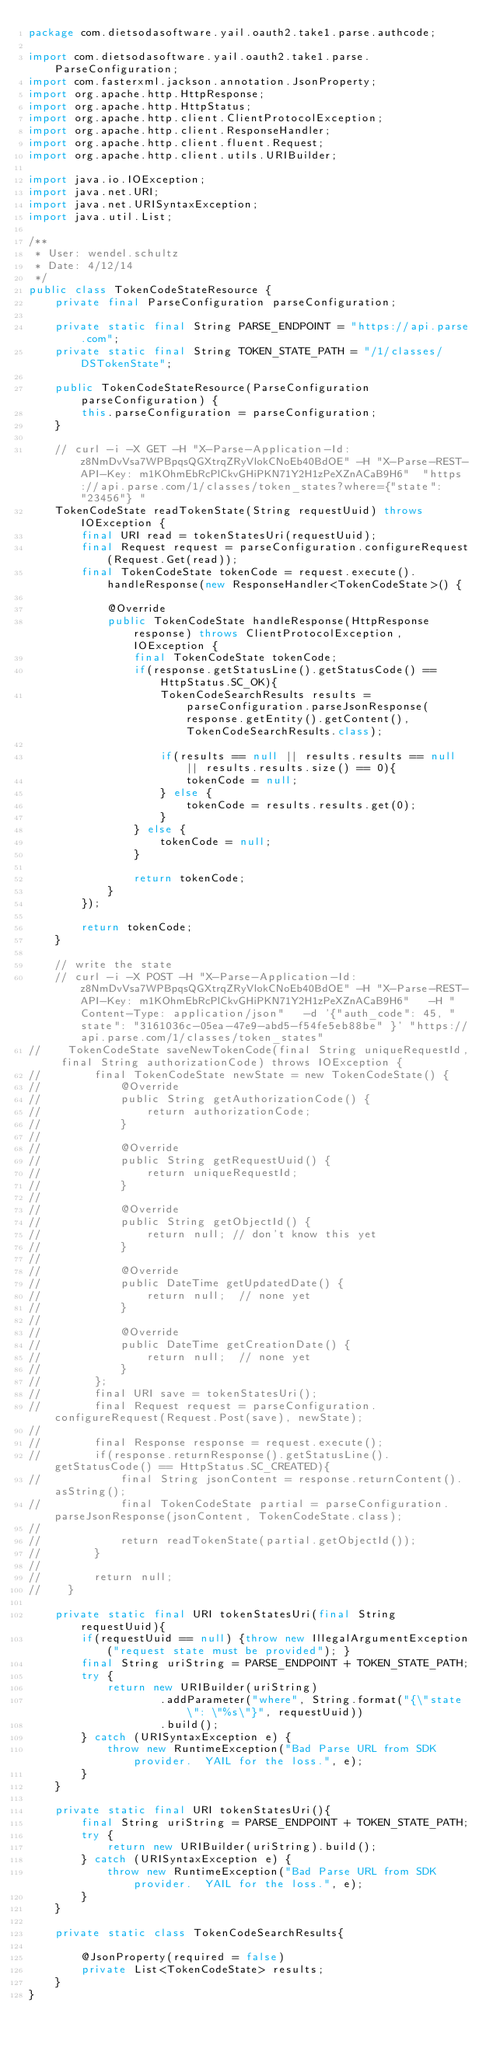<code> <loc_0><loc_0><loc_500><loc_500><_Java_>package com.dietsodasoftware.yail.oauth2.take1.parse.authcode;

import com.dietsodasoftware.yail.oauth2.take1.parse.ParseConfiguration;
import com.fasterxml.jackson.annotation.JsonProperty;
import org.apache.http.HttpResponse;
import org.apache.http.HttpStatus;
import org.apache.http.client.ClientProtocolException;
import org.apache.http.client.ResponseHandler;
import org.apache.http.client.fluent.Request;
import org.apache.http.client.utils.URIBuilder;

import java.io.IOException;
import java.net.URI;
import java.net.URISyntaxException;
import java.util.List;

/**
 * User: wendel.schultz
 * Date: 4/12/14
 */
public class TokenCodeStateResource {
    private final ParseConfiguration parseConfiguration;

    private static final String PARSE_ENDPOINT = "https://api.parse.com";
    private static final String TOKEN_STATE_PATH = "/1/classes/DSTokenState";

    public TokenCodeStateResource(ParseConfiguration parseConfiguration) {
        this.parseConfiguration = parseConfiguration;
    }

    // curl -i -X GET -H "X-Parse-Application-Id: z8NmDvVsa7WPBpqsQGXtrqZRyVlokCNoEb40BdOE" -H "X-Parse-REST-API-Key: m1KOhmEbRcPlCkvGHiPKN71Y2H1zPeXZnACaB9H6"  "https://api.parse.com/1/classes/token_states?where={"state": "23456"} "
    TokenCodeState readTokenState(String requestUuid) throws IOException {
        final URI read = tokenStatesUri(requestUuid);
        final Request request = parseConfiguration.configureRequest(Request.Get(read));
        final TokenCodeState tokenCode = request.execute().handleResponse(new ResponseHandler<TokenCodeState>() {

            @Override
            public TokenCodeState handleResponse(HttpResponse response) throws ClientProtocolException, IOException {
                final TokenCodeState tokenCode;
                if(response.getStatusLine().getStatusCode() == HttpStatus.SC_OK){
                    TokenCodeSearchResults results = parseConfiguration.parseJsonResponse(response.getEntity().getContent(), TokenCodeSearchResults.class);

                    if(results == null || results.results == null || results.results.size() == 0){
                        tokenCode = null;
                    } else {
                        tokenCode = results.results.get(0);
                    }
                } else {
                    tokenCode = null;
                }

                return tokenCode;
            }
        });

        return tokenCode;
    }

    // write the state
    // curl -i -X POST -H "X-Parse-Application-Id: z8NmDvVsa7WPBpqsQGXtrqZRyVlokCNoEb40BdOE" -H "X-Parse-REST-API-Key: m1KOhmEbRcPlCkvGHiPKN71Y2H1zPeXZnACaB9H6"   -H "Content-Type: application/json"   -d '{"auth_code": 45, "state": "3161036c-05ea-47e9-abd5-f54fe5eb88be" }' "https://api.parse.com/1/classes/token_states"
//    TokenCodeState saveNewTokenCode(final String uniqueRequestId, final String authorizationCode) throws IOException {
//        final TokenCodeState newState = new TokenCodeState() {
//            @Override
//            public String getAuthorizationCode() {
//                return authorizationCode;
//            }
//
//            @Override
//            public String getRequestUuid() {
//                return uniqueRequestId;
//            }
//
//            @Override
//            public String getObjectId() {
//                return null; // don't know this yet
//            }
//
//            @Override
//            public DateTime getUpdatedDate() {
//                return null;  // none yet
//            }
//
//            @Override
//            public DateTime getCreationDate() {
//                return null;  // none yet
//            }
//        };
//        final URI save = tokenStatesUri();
//        final Request request = parseConfiguration.configureRequest(Request.Post(save), newState);
//
//        final Response response = request.execute();
//        if(response.returnResponse().getStatusLine().getStatusCode() == HttpStatus.SC_CREATED){
//            final String jsonContent = response.returnContent().asString();
//            final TokenCodeState partial = parseConfiguration.parseJsonResponse(jsonContent, TokenCodeState.class);
//
//            return readTokenState(partial.getObjectId());
//        }
//
//        return null;
//    }

    private static final URI tokenStatesUri(final String requestUuid){
        if(requestUuid == null) {throw new IllegalArgumentException("request state must be provided"); }
        final String uriString = PARSE_ENDPOINT + TOKEN_STATE_PATH;
        try {
            return new URIBuilder(uriString)
                    .addParameter("where", String.format("{\"state\": \"%s\"}", requestUuid))
                    .build();
        } catch (URISyntaxException e) {
            throw new RuntimeException("Bad Parse URL from SDK provider.  YAIL for the loss.", e);
        }
    }

    private static final URI tokenStatesUri(){
        final String uriString = PARSE_ENDPOINT + TOKEN_STATE_PATH;
        try {
            return new URIBuilder(uriString).build();
        } catch (URISyntaxException e) {
            throw new RuntimeException("Bad Parse URL from SDK provider.  YAIL for the loss.", e);
        }
    }

    private static class TokenCodeSearchResults{

        @JsonProperty(required = false)
        private List<TokenCodeState> results;
    }
}
</code> 